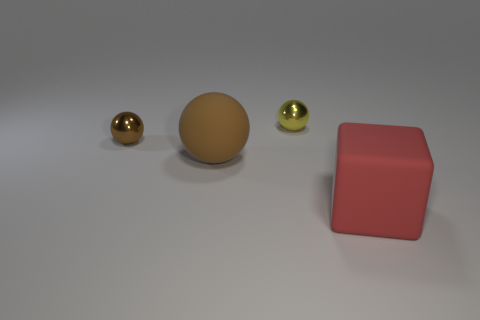Add 3 tiny gray matte cylinders. How many objects exist? 7 Subtract all blocks. How many objects are left? 3 Add 2 cyan metal spheres. How many cyan metal spheres exist? 2 Subtract 0 purple spheres. How many objects are left? 4 Subtract all tiny gray cylinders. Subtract all brown rubber spheres. How many objects are left? 3 Add 2 brown metallic spheres. How many brown metallic spheres are left? 3 